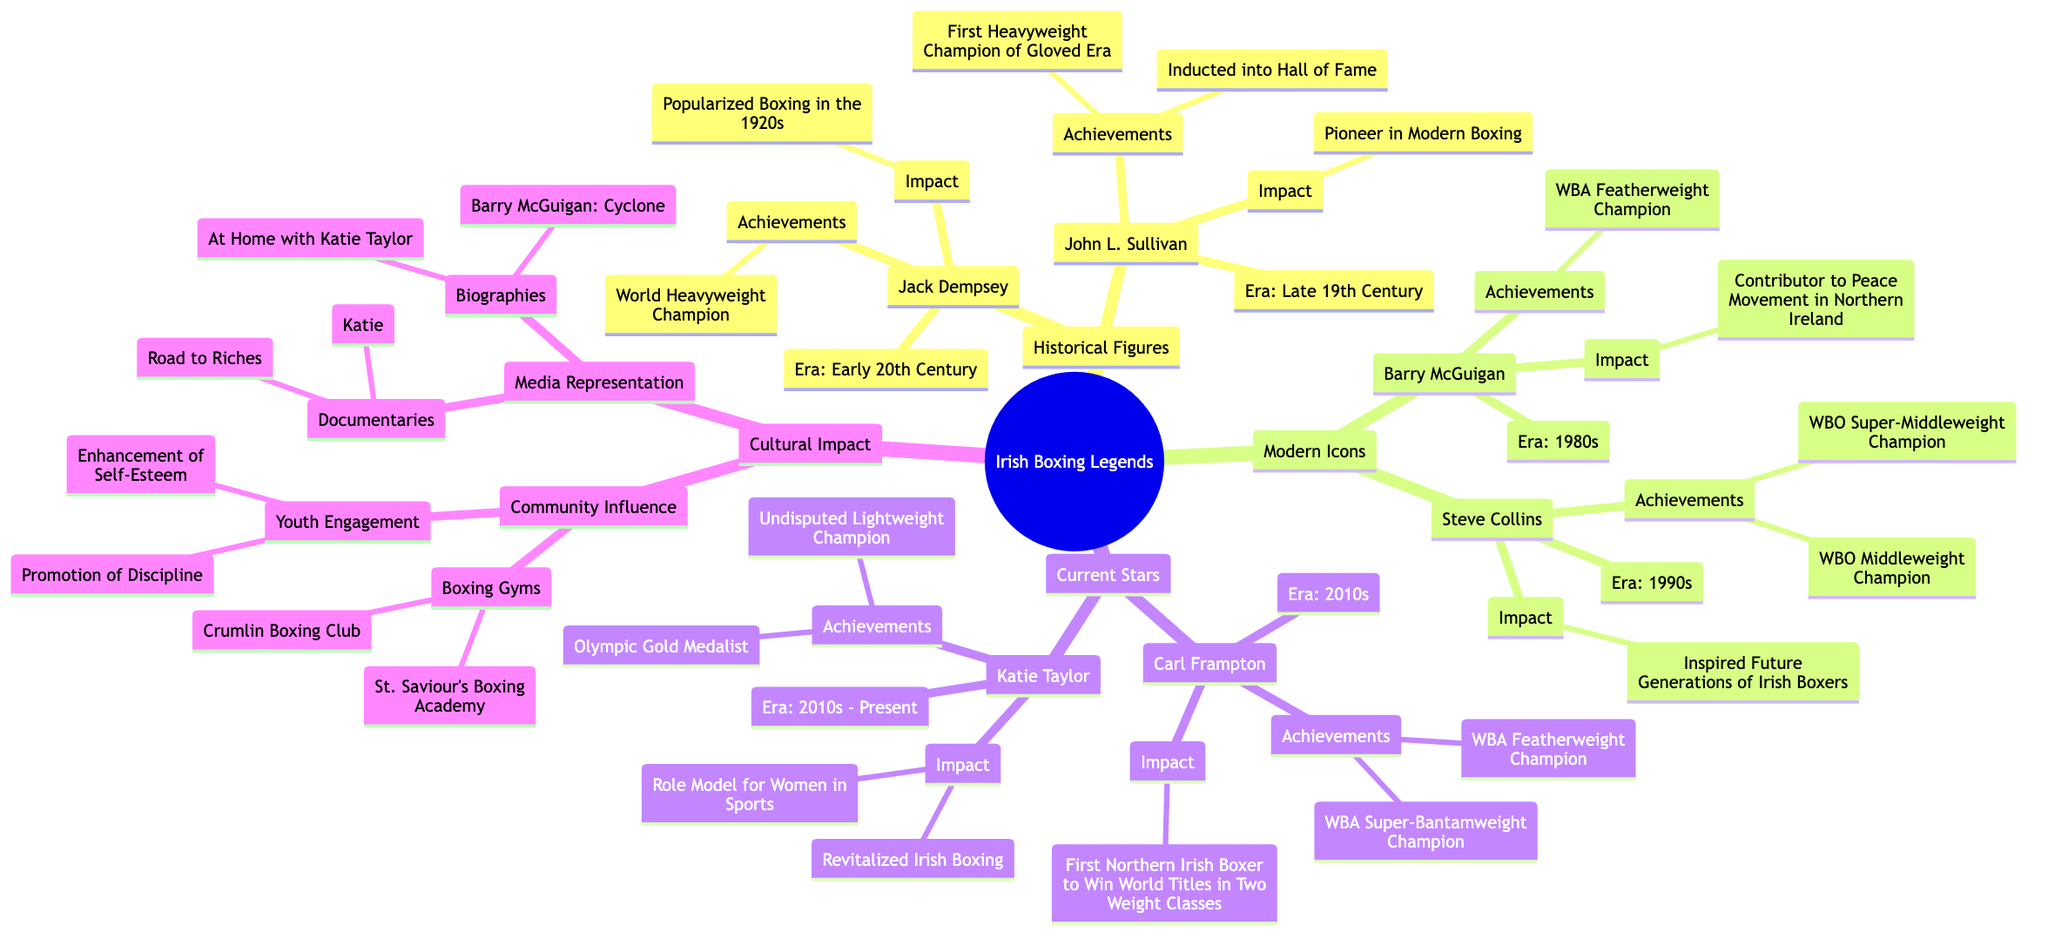What era is associated with John L. Sullivan? From the diagram under "Historical Figures," John L. Sullivan is associated with the "Late 19th Century" era, as specified directly next to his name.
Answer: Late 19th Century How many achievements are listed for Barry McGuigan? In the section for "Barry McGuigan" under "Modern Icons," there is one achievement listed, which is "WBA Featherweight Champion." Therefore, the answer is counted directly from that node.
Answer: 1 What is Carl Frampton known for in boxing? According to the diagram, Carl Frampton's known achievement is being "First Northern Irish Boxer to Win World Titles in Two Weight Classes," which is captured directly under his impact.
Answer: First Northern Irish Boxer to Win World Titles in Two Weight Classes Which legend contributed to the Peace Movement in Northern Ireland? By examining the "Impact" section under "Barry McGuigan," it states that he is a "Contributor to Peace Movement in Northern Ireland," indicating his role directly.
Answer: Barry McGuigan What two boxing gyms are mentioned in the Cultural Impact section? The diagram lists two boxing gyms under "Boxing Gyms" in the "Community Influence" subsection: "St. Saviour's Boxing Academy" and "Crumlin Boxing Club," which can be directly found in the appropriate area of the mind map.
Answer: St. Saviour's Boxing Academy, Crumlin Boxing Club How many different eras are represented in the legends of Irish boxing? By counting each distinct era mentioned for the legends in the diagram, we have "Late 19th Century," "Early 20th Century," "1980s," "1990s," and "2010s - Present." This gives a total of five unique eras.
Answer: 5 What is Katie Taylor's notable achievement in boxing? The diagram highlights her as an "Olympic Gold Medalist" under her achievements, which is a key accomplishment listed in her section.
Answer: Olympic Gold Medalist Which two types of media representation are highlighted in the diagram? Under "Media Representation" in the "Cultural Impact" section, the diagram lists "Documentaries" and "Biographies" as the two types of media, which are clearly defined in distinct nodes.
Answer: Documentaries, Biographies Name the boxer from the 1990s who inspired future generations of Irish boxers. Referring to the "Impact" section of "Steve Collins" in the "Modern Icons," it indicates that he "Inspired Future Generations of Irish Boxers."
Answer: Steve Collins 